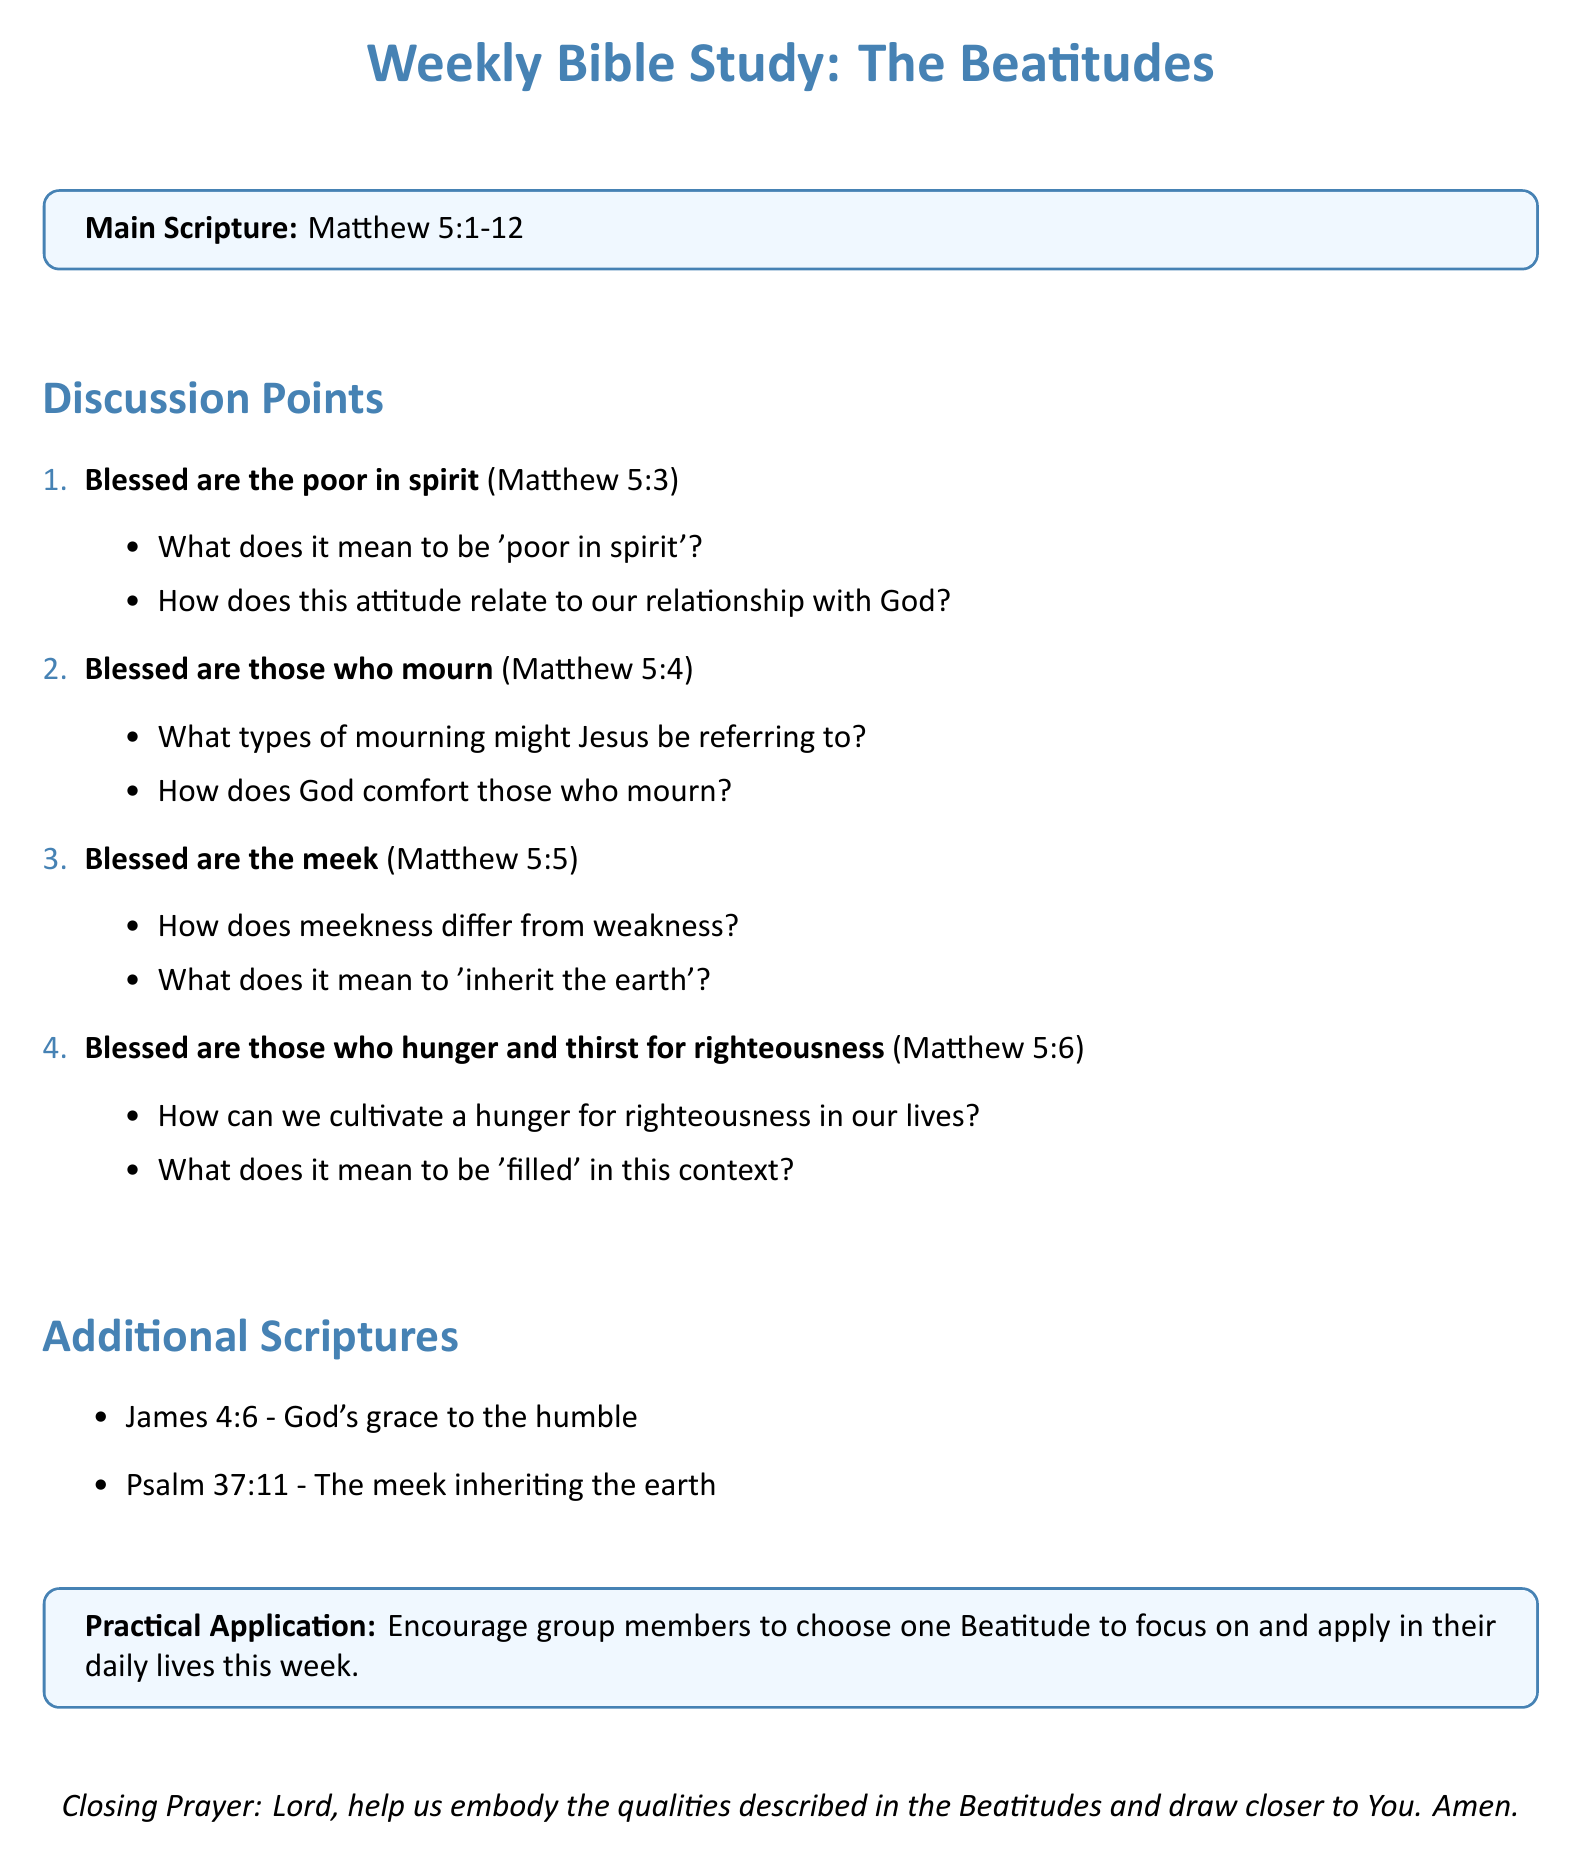What is the main scripture for the study? The main scripture is explicitly stated under the title of the document.
Answer: Matthew 5:1-12 What is the topic of the first discussion point? The first discussion point is labeled with a specific topic related to the Beatitudes.
Answer: Blessed are the poor in spirit What verse corresponds to the Beatitude about those who mourn? Each discussion point includes a specific verse reference related to the topic.
Answer: Matthew 5:4 How many discussion points are listed in the document? The document outlines a specific number of discussion points regarding the Beatitudes.
Answer: 4 What practical application is suggested for the group? There is a dedicated section providing a practical application for group members.
Answer: Encourage group members to choose one Beatitude to focus on and apply in their daily lives this week What closing prayer is included in the document? The document concludes with a specified prayer that aligns with the discussion theme.
Answer: Lord, help us embody the qualities described in the Beatitudes and draw closer to You. Amen What is the reference for the scripture that mentions God's grace to the humble? The document provides references to other scriptures that relate to the main content.
Answer: James 4:6 What does the meek inherit according to Psalm 37:11? Additional scriptures are provided alongside their relevant themes.
Answer: The earth 